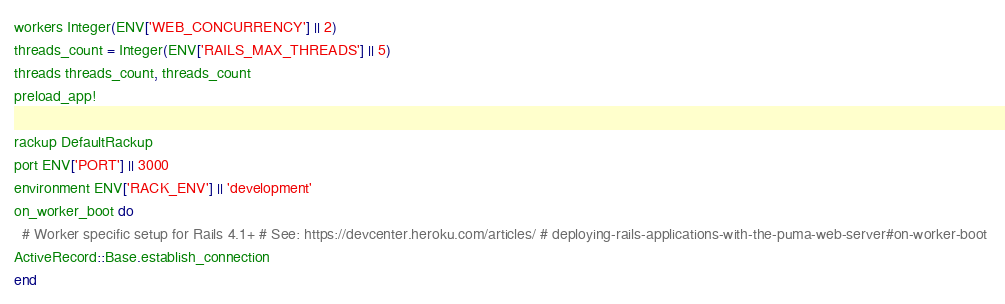<code> <loc_0><loc_0><loc_500><loc_500><_Ruby_>workers Integer(ENV['WEB_CONCURRENCY'] || 2)
threads_count = Integer(ENV['RAILS_MAX_THREADS'] || 5)
threads threads_count, threads_count 
preload_app! 

rackup DefaultRackup 
port ENV['PORT'] || 3000 
environment ENV['RACK_ENV'] || 'development' 
on_worker_boot do 
  # Worker specific setup for Rails 4.1+ # See: https://devcenter.heroku.com/articles/ # deploying-rails-applications-with-the-puma-web-server#on-worker-boot 
ActiveRecord::Base.establish_connection 
end</code> 